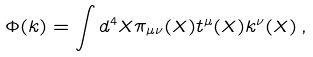Convert formula to latex. <formula><loc_0><loc_0><loc_500><loc_500>\Phi ( k ) = \int d ^ { 4 } X \pi _ { \mu \nu } ( X ) t ^ { \mu } ( X ) k ^ { \nu } ( X ) \, ,</formula> 